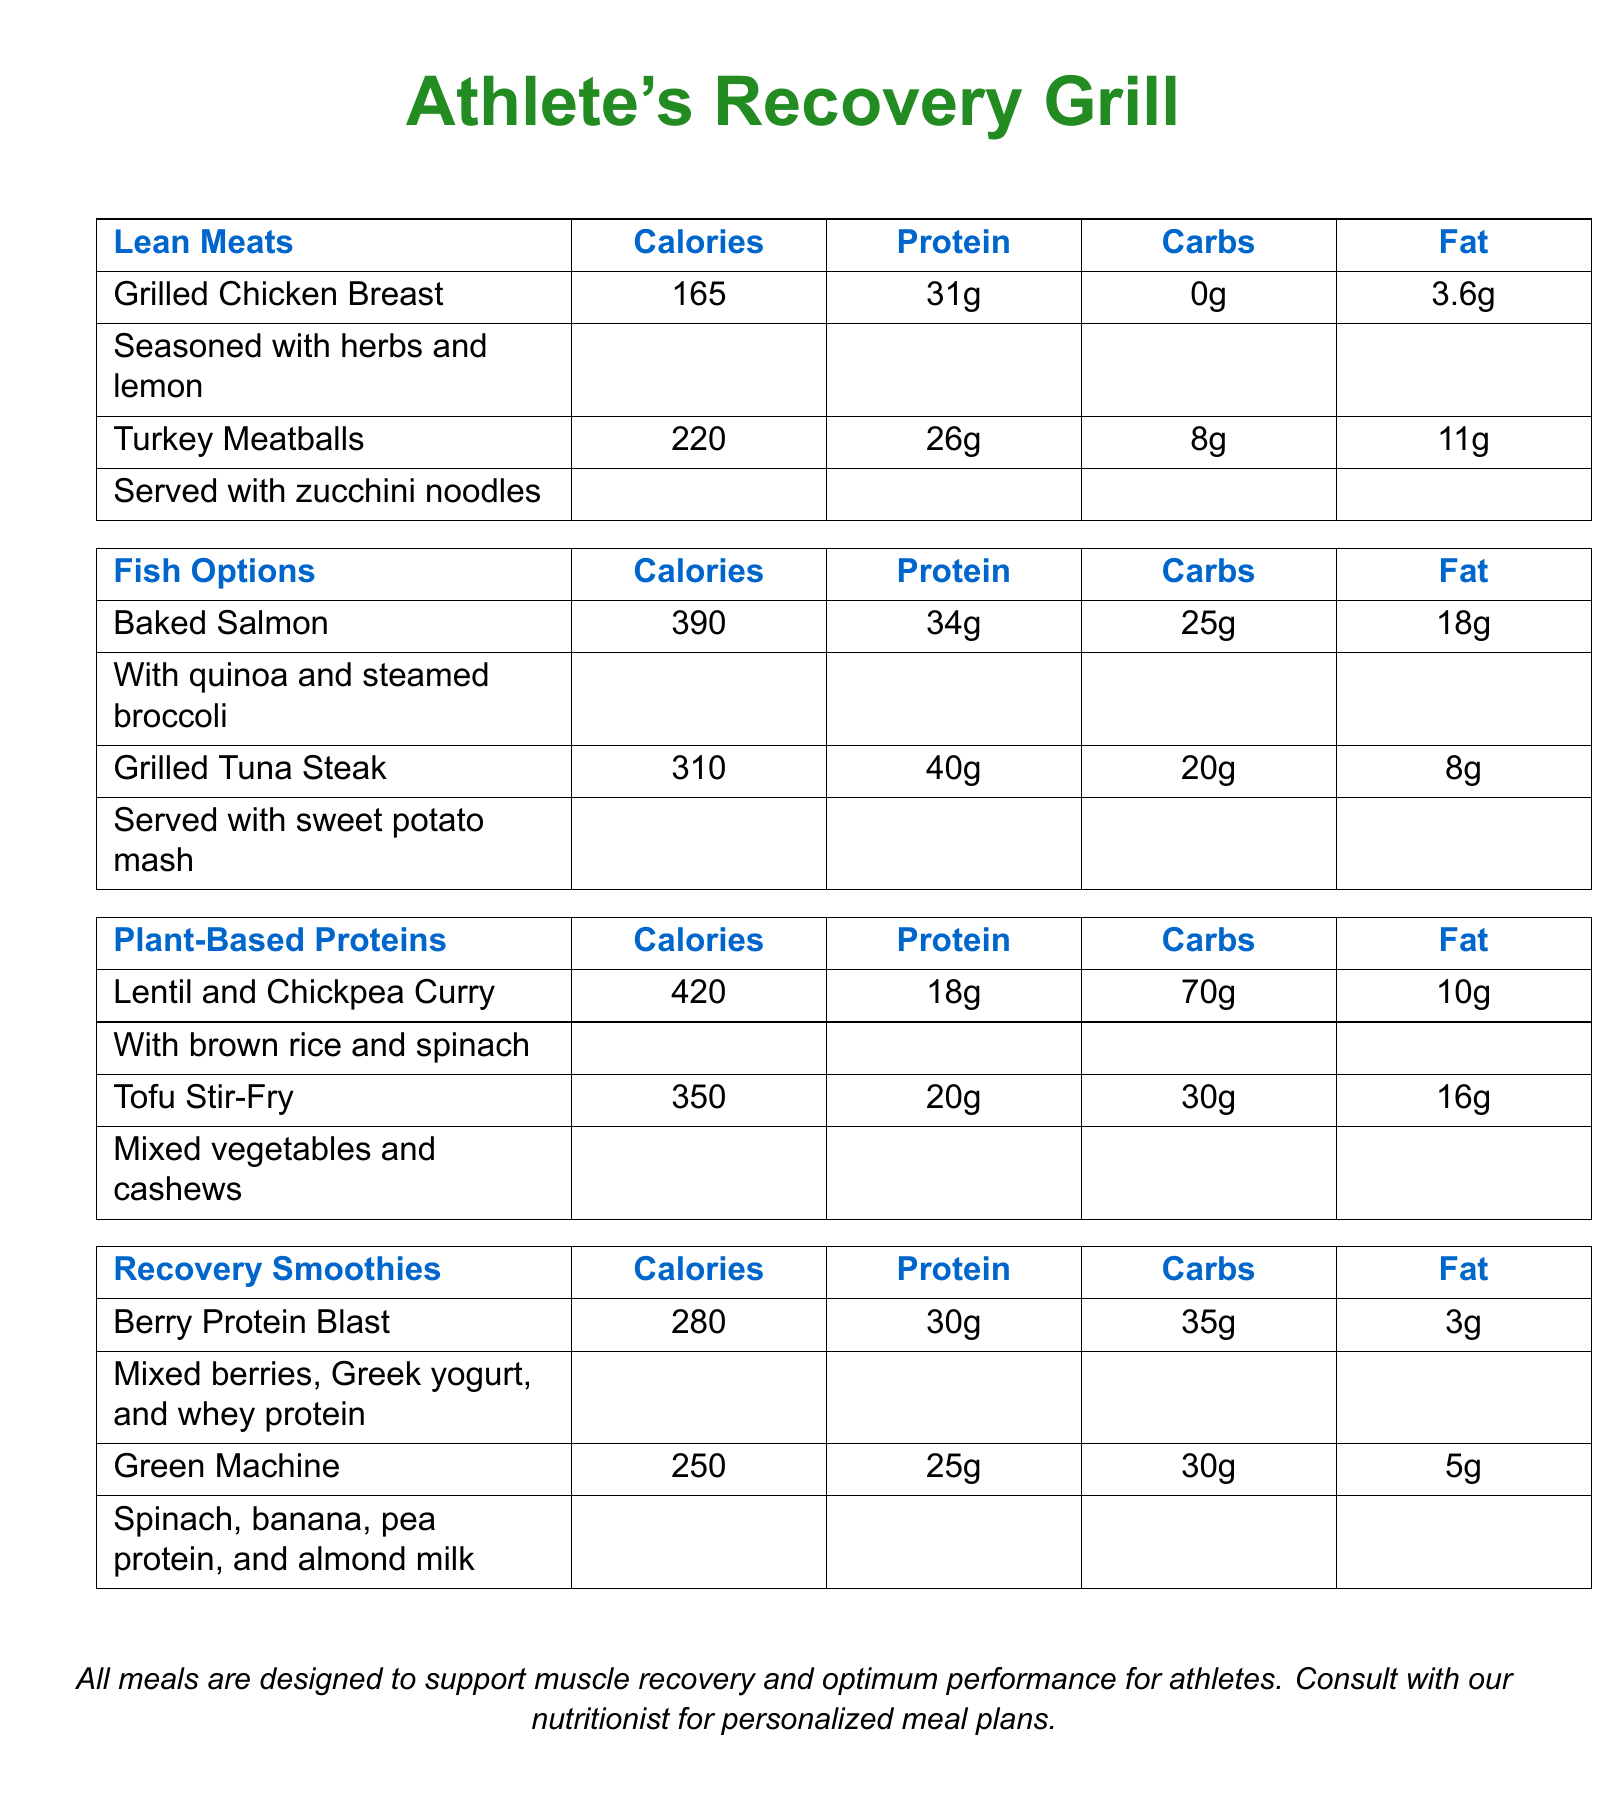What are the main categories of meals on the menu? The menu includes categories for Lean Meats, Fish Options, Plant-Based Proteins, and Recovery Smoothies.
Answer: Lean Meats, Fish Options, Plant-Based Proteins, Recovery Smoothies How many grams of protein are in the Baked Salmon? The Baked Salmon has 34 grams of protein according to the menu.
Answer: 34g What is the calorie count for the Grilled Chicken Breast? The calorie count is specifically listed as 165 calories for the Grilled Chicken Breast.
Answer: 165 Which plant-based dish has the highest calorie count? The Lentil and Chickpea Curry has the highest calorie count at 420 calories.
Answer: 420 What is the total protein content in Tofu Stir-Fry? The document shows Tofu Stir-Fry has a protein content of 20 grams.
Answer: 20g How many grams of fat does the Berry Protein Blast contain? The Berry Protein Blast is noted to have 3 grams of fat.
Answer: 3g What meal is served with zucchini noodles? The Turkey Meatballs are specifically served with zucchini noodles.
Answer: Turkey Meatballs Which smoothie has more carbohydrates, Berry Protein Blast or Green Machine? The Berry Protein Blast has 35 grams of carbohydrates, while the Green Machine has 30 grams, indicating Berry Protein Blast has more.
Answer: Berry Protein Blast What is the suggested consult alongside the meal plan? The document advises consulting with a nutritionist for personalized meal plans.
Answer: Nutritionist 